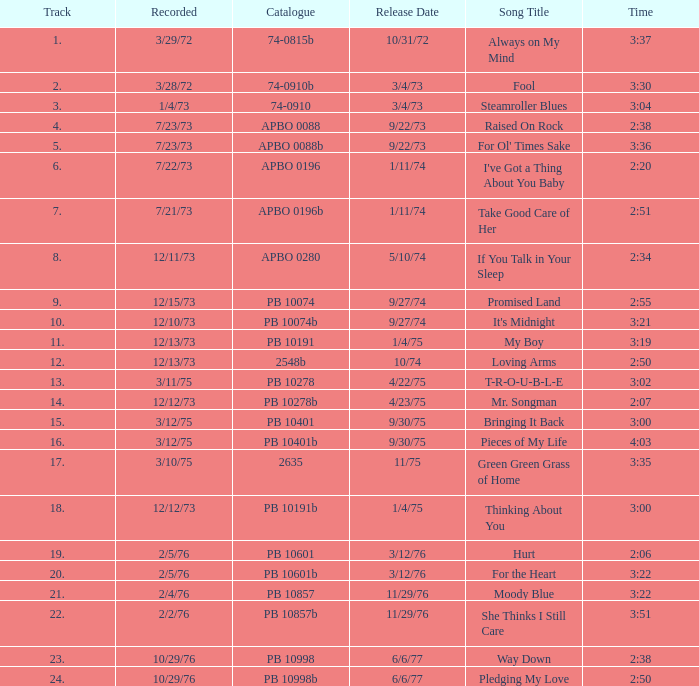What is the track with the catalog number apbo 0280? 8.0. 